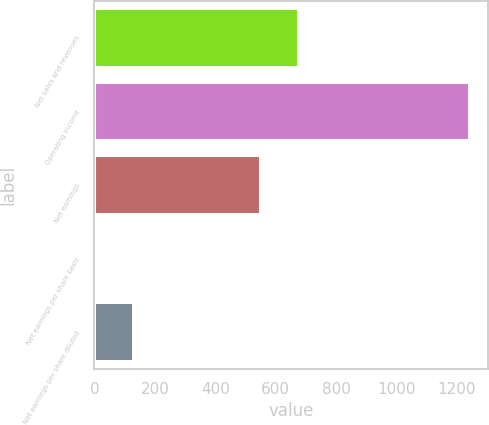Convert chart to OTSL. <chart><loc_0><loc_0><loc_500><loc_500><bar_chart><fcel>Net sales and revenues<fcel>Operating income<fcel>Net earnings<fcel>Net earnings per share basic<fcel>Net earnings per share diluted<nl><fcel>673.96<fcel>1242<fcel>550<fcel>2.45<fcel>126.41<nl></chart> 